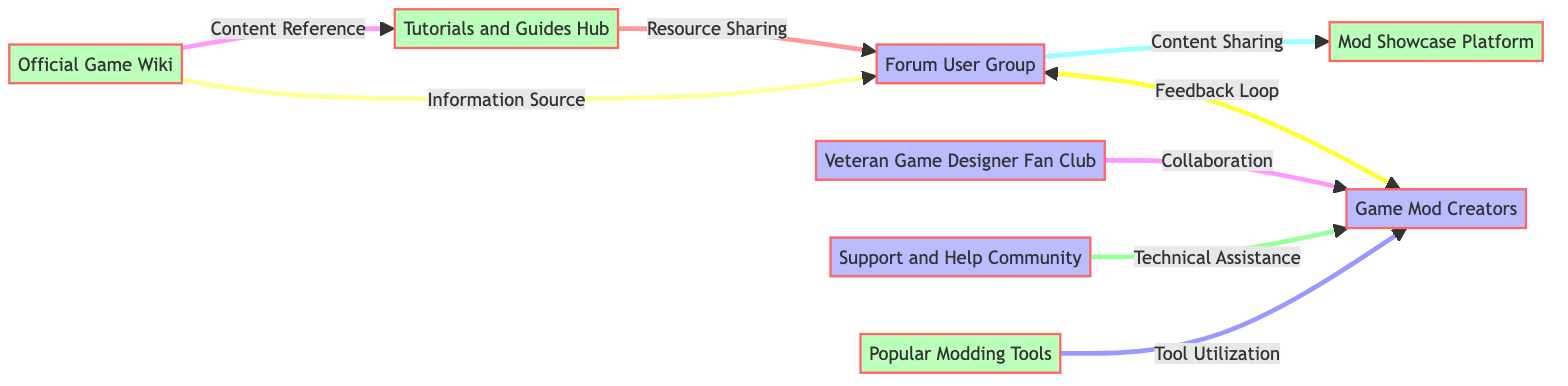What is the total number of nodes in the diagram? The diagram contains eight distinct nodes: Forum User Group, Game Mod Creators, Veteran Game Designer Fan Club, Mod Showcase Platform, Tutorials and Guides Hub, Support and Help Community, Popular Modding Tools, and Official Game Wiki.
Answer: 8 What type of relationship exists between the Forum User Group and Game Mod Creators? The diagram shows a bi-directional arrow labeled "Feedback Loop" connecting the Forum User Group and Game Mod Creators, indicating a reciprocal relationship where feedback is shared.
Answer: Feedback Loop Which node has a direct connection to the Mod Showcase Platform? The Forum User Group has a direct connection to the Mod Showcase Platform, as shown by an arrow labeled "Content Sharing" pointing from Forum User Group to Mod Showcase Platform.
Answer: Forum User Group What is the main function of the Tutorials and Guides Hub in relation to the Forum User Group? The arrow from Tutorials and Guides Hub to Forum User Group is labeled "Resource Sharing," indicating that the hub provides resources that are shared with the Forum User Group.
Answer: Resource Sharing Which community provides technical assistance to the Game Mod Creators? The arrow from Support and Help Community to Game Mod Creators is labeled "Technical Assistance," indicating that the Support and Help Community is responsible for providing this support.
Answer: Support and Help Community Are there any connections from the Official Game Wiki? Yes, the Official Game Wiki has two connections: one to the Forum User Group labeled "Information Source" and another to the Tutorials and Guides Hub labeled "Content Reference."
Answer: Yes How many edges are present in the diagram? The diagram shows a total of eight edges connecting various nodes, illustrating the interactions and relationships among them.
Answer: 8 Which group collaborates directly with the Game Mod Creators? The Veteran Game Designer Fan Club collaborates directly with the Game Mod Creators as indicated by the arrow labeled "Collaboration" pointing from the fan club to the creators.
Answer: Veteran Game Designer Fan Club 